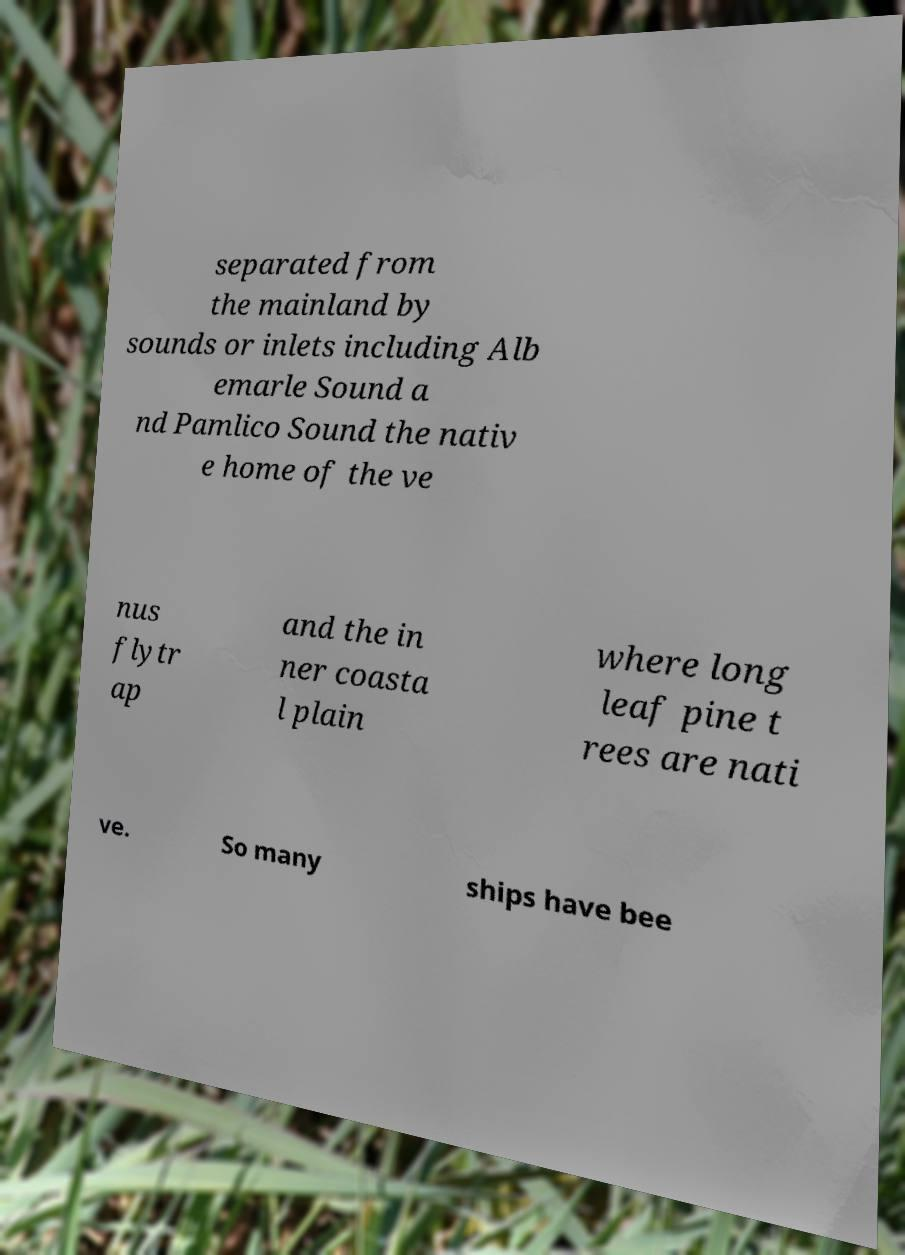Please read and relay the text visible in this image. What does it say? separated from the mainland by sounds or inlets including Alb emarle Sound a nd Pamlico Sound the nativ e home of the ve nus flytr ap and the in ner coasta l plain where long leaf pine t rees are nati ve. So many ships have bee 